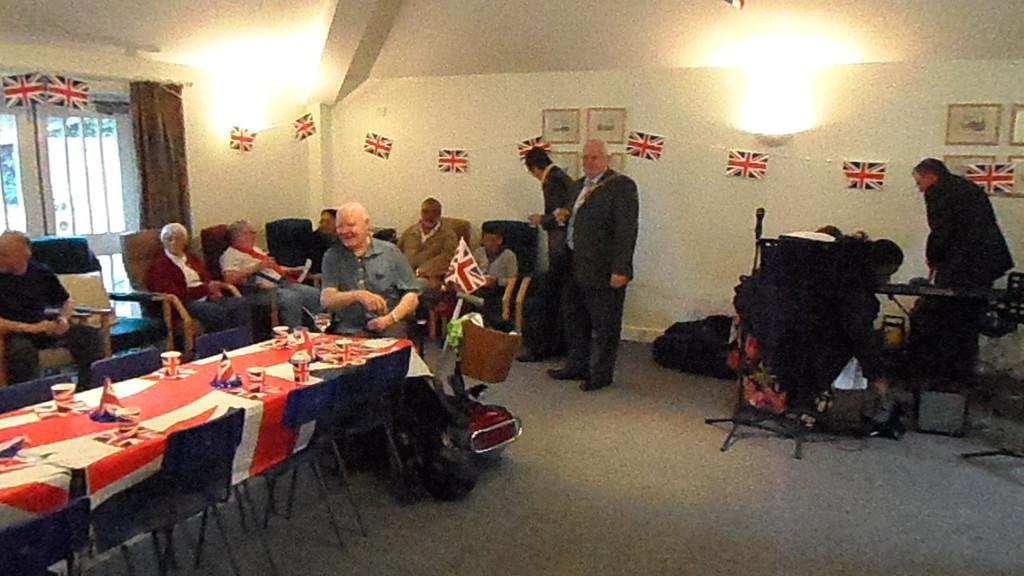Please provide a concise description of this image. This picture describes about group of people few are seated on the chair and few are standing, in front of them we can see cups, plates on the table, and also we can see some baggage in front of them, in the right side of the image we can see some musical instruments. 